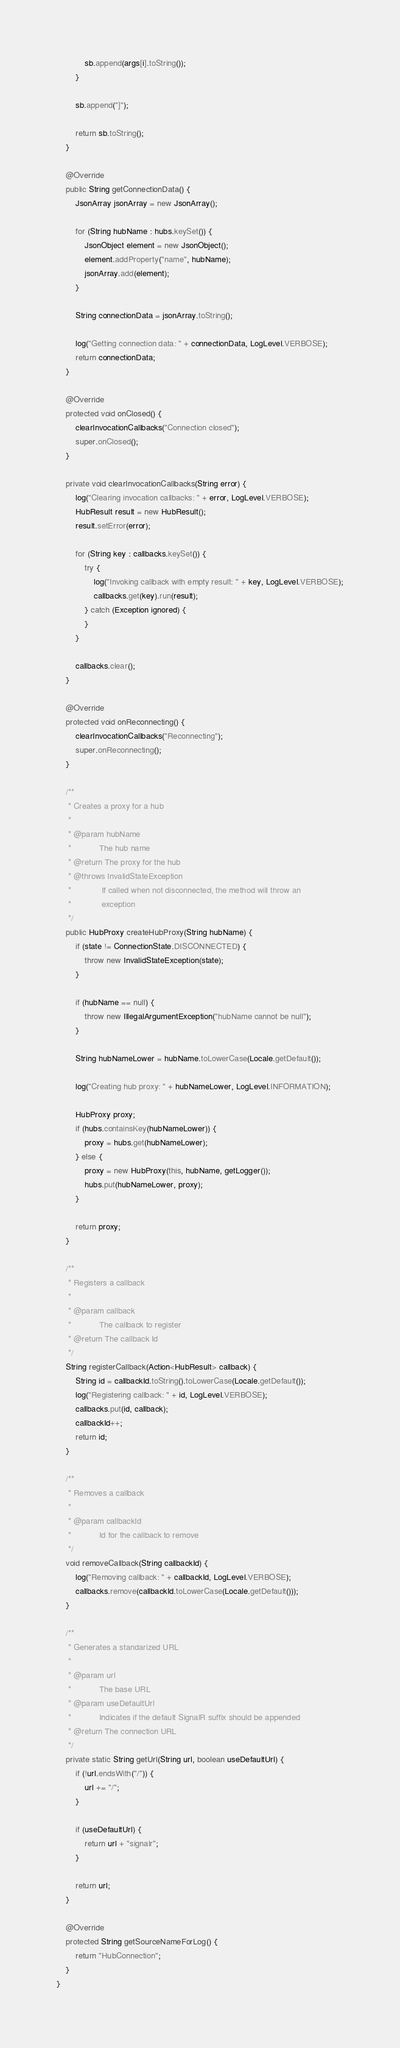Convert code to text. <code><loc_0><loc_0><loc_500><loc_500><_Java_>            sb.append(args[i].toString());
        }

        sb.append("]");

        return sb.toString();
    }

    @Override
    public String getConnectionData() {
        JsonArray jsonArray = new JsonArray();

        for (String hubName : hubs.keySet()) {
            JsonObject element = new JsonObject();
            element.addProperty("name", hubName);
            jsonArray.add(element);
        }

        String connectionData = jsonArray.toString();

        log("Getting connection data: " + connectionData, LogLevel.VERBOSE);
        return connectionData;
    }

    @Override
    protected void onClosed() {
        clearInvocationCallbacks("Connection closed");
        super.onClosed();
    }

    private void clearInvocationCallbacks(String error) {
        log("Clearing invocation callbacks: " + error, LogLevel.VERBOSE);
        HubResult result = new HubResult();
        result.setError(error);

        for (String key : callbacks.keySet()) {
            try {
                log("Invoking callback with empty result: " + key, LogLevel.VERBOSE);
                callbacks.get(key).run(result);
            } catch (Exception ignored) {
            }
        }

        callbacks.clear();
    }

    @Override
    protected void onReconnecting() {
        clearInvocationCallbacks("Reconnecting");
        super.onReconnecting();
    }

    /**
     * Creates a proxy for a hub
     * 
     * @param hubName
     *            The hub name
     * @return The proxy for the hub
     * @throws InvalidStateException
     *             If called when not disconnected, the method will throw an
     *             exception
     */
    public HubProxy createHubProxy(String hubName) {
        if (state != ConnectionState.DISCONNECTED) {
            throw new InvalidStateException(state);
        }

        if (hubName == null) {
            throw new IllegalArgumentException("hubName cannot be null");
        }

        String hubNameLower = hubName.toLowerCase(Locale.getDefault());

        log("Creating hub proxy: " + hubNameLower, LogLevel.INFORMATION);

        HubProxy proxy;
        if (hubs.containsKey(hubNameLower)) {
            proxy = hubs.get(hubNameLower);
        } else {
            proxy = new HubProxy(this, hubName, getLogger());
            hubs.put(hubNameLower, proxy);
        }

        return proxy;
    }

    /**
     * Registers a callback
     * 
     * @param callback
     *            The callback to register
     * @return The callback Id
     */
    String registerCallback(Action<HubResult> callback) {
        String id = callbackId.toString().toLowerCase(Locale.getDefault());
        log("Registering callback: " + id, LogLevel.VERBOSE);
        callbacks.put(id, callback);
        callbackId++;
        return id;
    }

    /**
     * Removes a callback
     * 
     * @param callbackId
     *            Id for the callback to remove
     */
    void removeCallback(String callbackId) {
        log("Removing callback: " + callbackId, LogLevel.VERBOSE);
        callbacks.remove(callbackId.toLowerCase(Locale.getDefault()));
    }

    /**
     * Generates a standarized URL
     * 
     * @param url
     *            The base URL
     * @param useDefaultUrl
     *            Indicates if the default SignalR suffix should be appended
     * @return The connection URL
     */
    private static String getUrl(String url, boolean useDefaultUrl) {
        if (!url.endsWith("/")) {
            url += "/";
        }

        if (useDefaultUrl) {
            return url + "signalr";
        }

        return url;
    }

    @Override
    protected String getSourceNameForLog() {
        return "HubConnection";
    }
}
</code> 